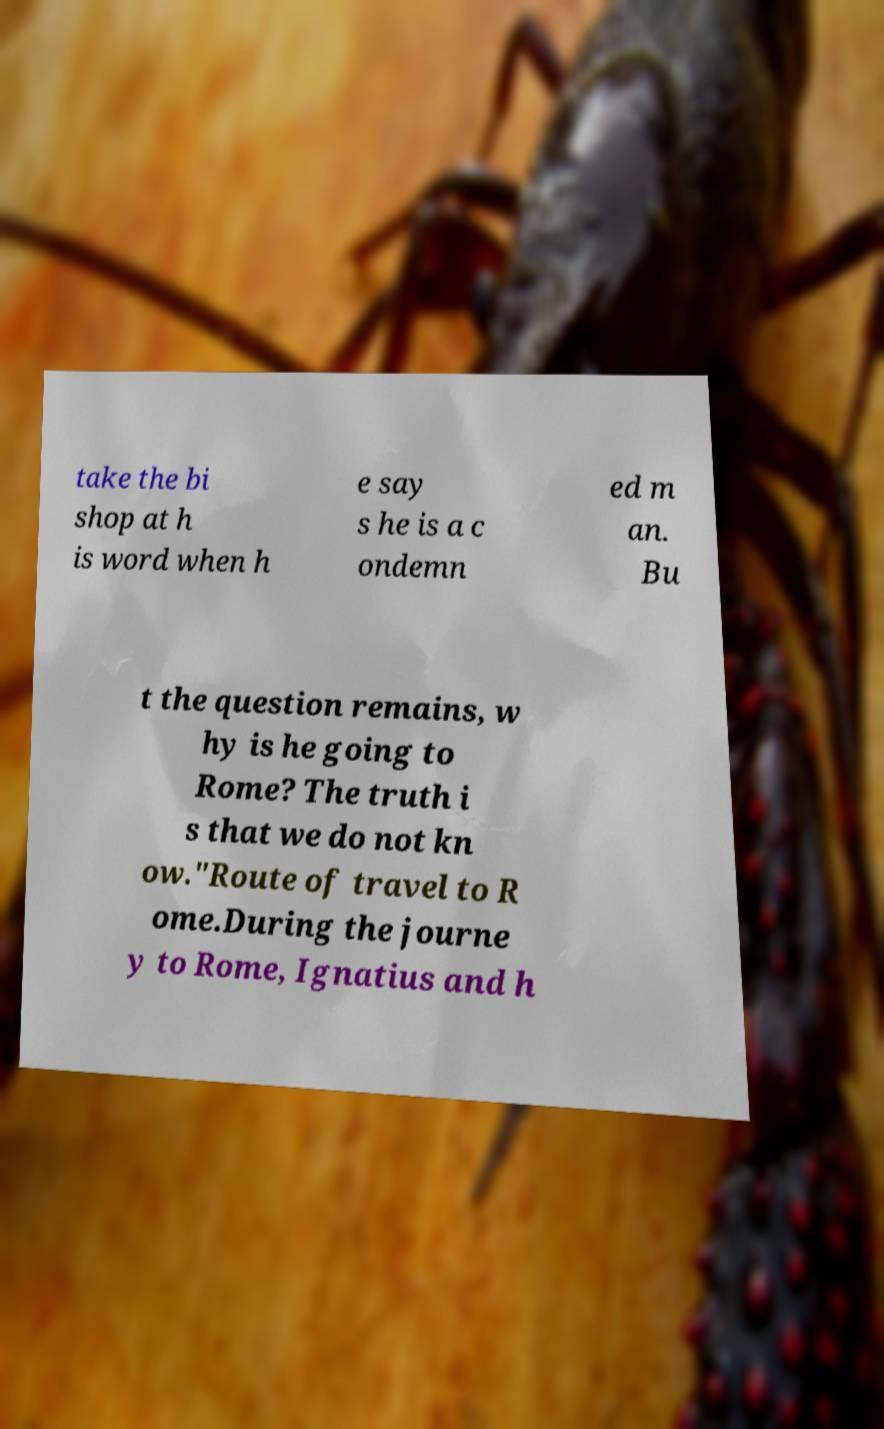Could you assist in decoding the text presented in this image and type it out clearly? take the bi shop at h is word when h e say s he is a c ondemn ed m an. Bu t the question remains, w hy is he going to Rome? The truth i s that we do not kn ow."Route of travel to R ome.During the journe y to Rome, Ignatius and h 